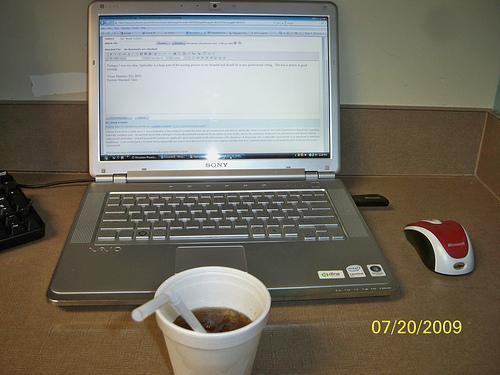How many cups are shown?
Give a very brief answer. 1. 